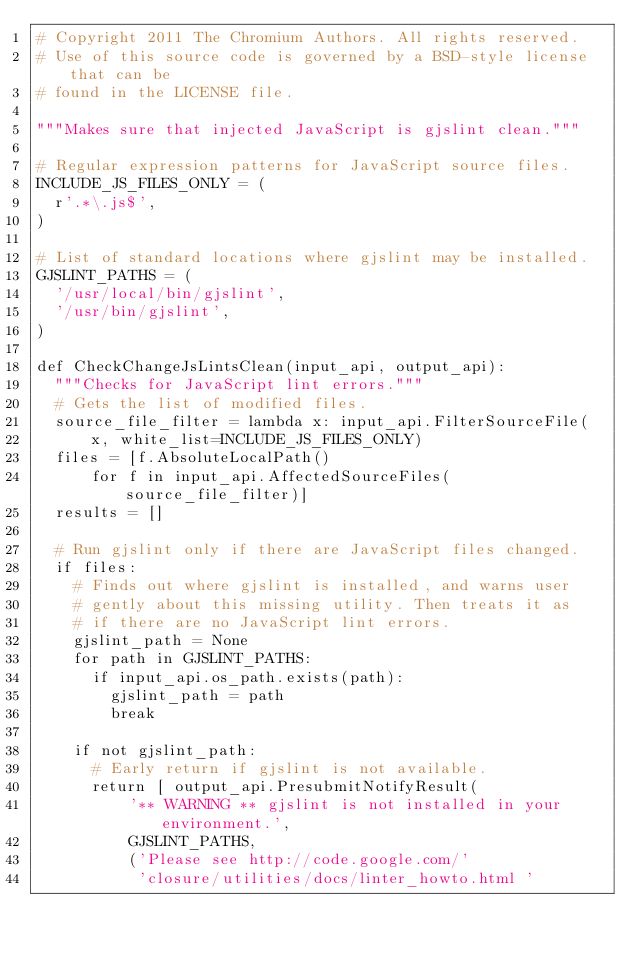<code> <loc_0><loc_0><loc_500><loc_500><_Python_># Copyright 2011 The Chromium Authors. All rights reserved.
# Use of this source code is governed by a BSD-style license that can be
# found in the LICENSE file.

"""Makes sure that injected JavaScript is gjslint clean."""

# Regular expression patterns for JavaScript source files.
INCLUDE_JS_FILES_ONLY = (
  r'.*\.js$',
)

# List of standard locations where gjslint may be installed.
GJSLINT_PATHS = (
  '/usr/local/bin/gjslint',
  '/usr/bin/gjslint',
)

def CheckChangeJsLintsClean(input_api, output_api):
  """Checks for JavaScript lint errors."""
  # Gets the list of modified files.
  source_file_filter = lambda x: input_api.FilterSourceFile(
      x, white_list=INCLUDE_JS_FILES_ONLY)
  files = [f.AbsoluteLocalPath()
      for f in input_api.AffectedSourceFiles(source_file_filter)]
  results = []

  # Run gjslint only if there are JavaScript files changed.
  if files:
    # Finds out where gjslint is installed, and warns user
    # gently about this missing utility. Then treats it as
    # if there are no JavaScript lint errors.
    gjslint_path = None
    for path in GJSLINT_PATHS:
      if input_api.os_path.exists(path):
        gjslint_path = path
        break

    if not gjslint_path:
      # Early return if gjslint is not available.
      return [ output_api.PresubmitNotifyResult(
          '** WARNING ** gjslint is not installed in your environment.',
          GJSLINT_PATHS,
          ('Please see http://code.google.com/'
           'closure/utilities/docs/linter_howto.html '</code> 